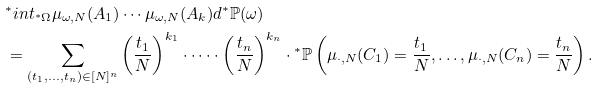Convert formula to latex. <formula><loc_0><loc_0><loc_500><loc_500>& ^ { * } i n t _ { { ^ { * } } \Omega } \mu _ { \omega , N } ( A _ { 1 } ) \cdots \mu _ { \omega , N } ( A _ { k } ) d { ^ { * } } \mathbb { P } ( \omega ) \\ & = \sum _ { ( t _ { 1 } , \dots , t _ { n } ) \in [ N ] ^ { n } } \left ( \frac { t _ { 1 } } { N } \right ) ^ { k _ { 1 } } \cdot \dots \cdot \left ( \frac { t _ { n } } { N } \right ) ^ { k _ { n } } \cdot { ^ { * } } \mathbb { P } \left ( \mu _ { \cdot , N } ( C _ { 1 } ) = \frac { t _ { 1 } } { N } , \dots , \mu _ { \cdot , N } ( C _ { n } ) = \frac { t _ { n } } { N } \right ) .</formula> 